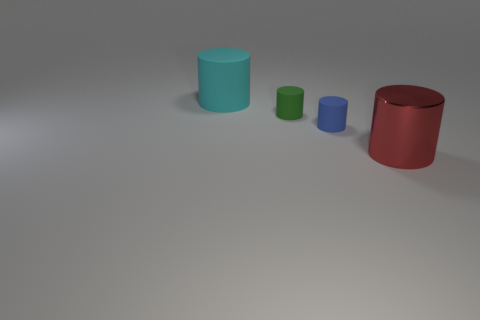Are there any other things that are the same material as the green thing?
Keep it short and to the point. Yes. There is a cylinder that is both right of the large rubber cylinder and behind the tiny blue cylinder; what is its material?
Provide a succinct answer. Rubber. There is a large cyan thing that is the same material as the green cylinder; what shape is it?
Make the answer very short. Cylinder. Are there any other things that have the same color as the large matte cylinder?
Your answer should be compact. No. Is the number of green matte things that are behind the green thing greater than the number of large matte cubes?
Your answer should be very brief. No. What is the blue cylinder made of?
Your answer should be compact. Rubber. How many green objects are the same size as the green cylinder?
Provide a short and direct response. 0. Is the number of tiny blue rubber cylinders to the left of the cyan rubber cylinder the same as the number of green cylinders that are in front of the red metallic object?
Your answer should be compact. Yes. Is the green cylinder made of the same material as the big cyan cylinder?
Keep it short and to the point. Yes. There is a tiny object right of the green object; are there any tiny blue things to the right of it?
Provide a short and direct response. No. 